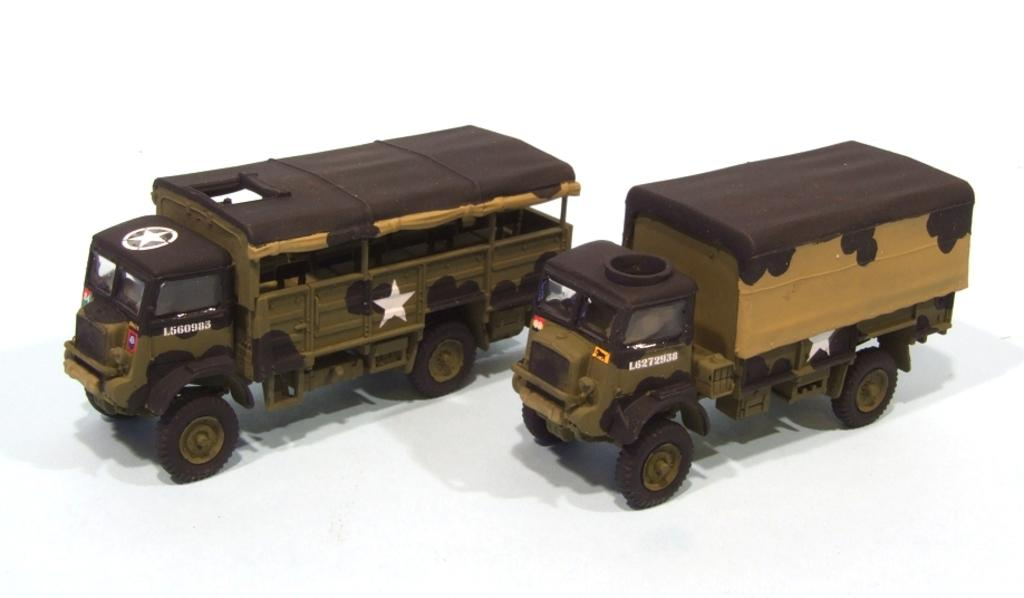What type of toys are present in the image? There are toy trucks in the image. Where are the toy trucks located? The toy trucks are present over a place. What type of church can be seen in the image? There is no church present in the image; it features toy trucks. What type of berry is being used as a decoration in the image? There is no berry present in the image; it features toy trucks. 